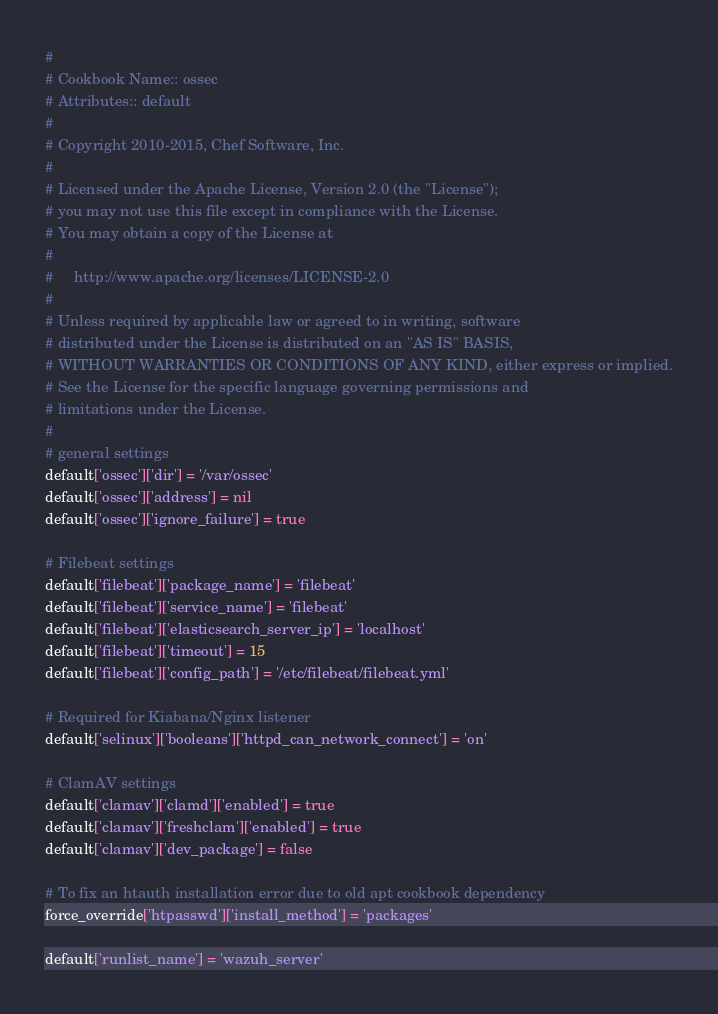Convert code to text. <code><loc_0><loc_0><loc_500><loc_500><_Ruby_>#
# Cookbook Name:: ossec
# Attributes:: default
#
# Copyright 2010-2015, Chef Software, Inc.
#
# Licensed under the Apache License, Version 2.0 (the "License");
# you may not use this file except in compliance with the License.
# You may obtain a copy of the License at
#
#     http://www.apache.org/licenses/LICENSE-2.0
#
# Unless required by applicable law or agreed to in writing, software
# distributed under the License is distributed on an "AS IS" BASIS,
# WITHOUT WARRANTIES OR CONDITIONS OF ANY KIND, either express or implied.
# See the License for the specific language governing permissions and
# limitations under the License.
#
# general settings
default['ossec']['dir'] = '/var/ossec'
default['ossec']['address'] = nil
default['ossec']['ignore_failure'] = true

# Filebeat settings
default['filebeat']['package_name'] = 'filebeat'
default['filebeat']['service_name'] = 'filebeat'
default['filebeat']['elasticsearch_server_ip'] = 'localhost'
default['filebeat']['timeout'] = 15
default['filebeat']['config_path'] = '/etc/filebeat/filebeat.yml'

# Required for Kiabana/Nginx listener
default['selinux']['booleans']['httpd_can_network_connect'] = 'on'

# ClamAV settings
default['clamav']['clamd']['enabled'] = true
default['clamav']['freshclam']['enabled'] = true
default['clamav']['dev_package'] = false

# To fix an htauth installation error due to old apt cookbook dependency
force_override['htpasswd']['install_method'] = 'packages'

default['runlist_name'] = 'wazuh_server'</code> 